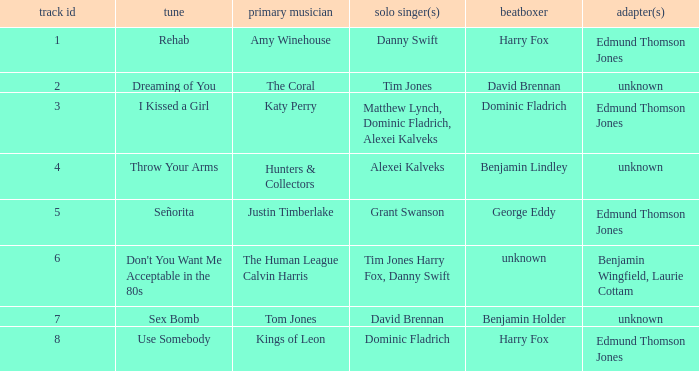Who is the percussionist for The Coral? David Brennan. 